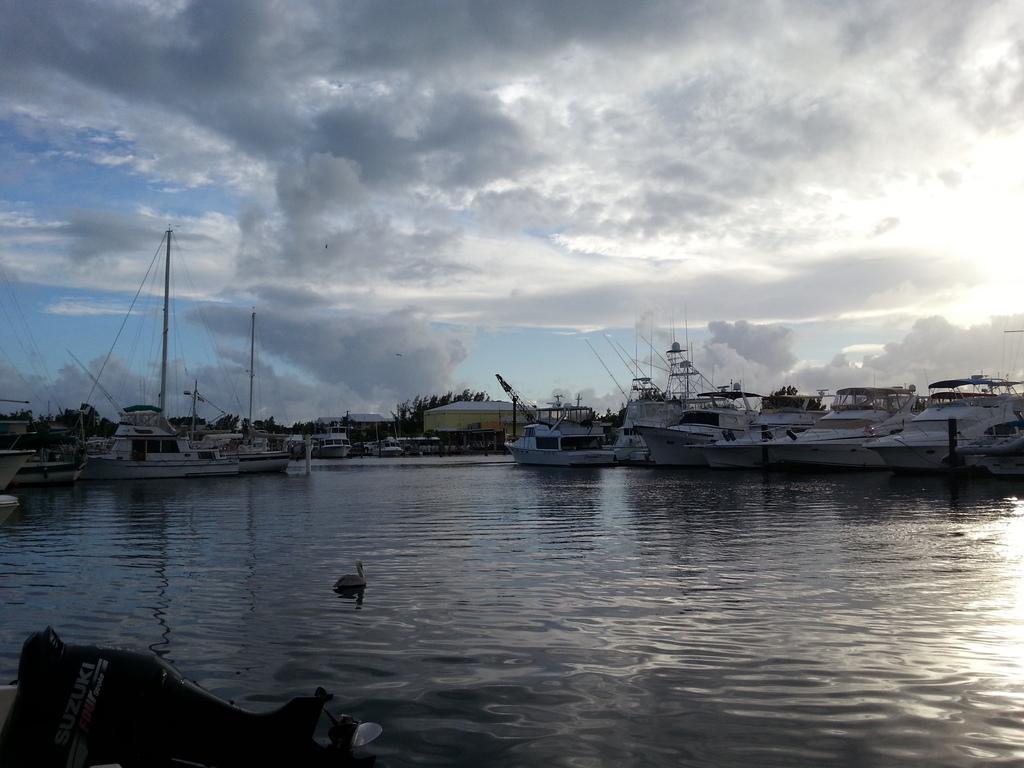Can you describe this image briefly? This image consists of boats in white color. At the bottom, there is water. At the top, there are clouds in the sky. And we can see a swan in the water. In the background, there are trees. 